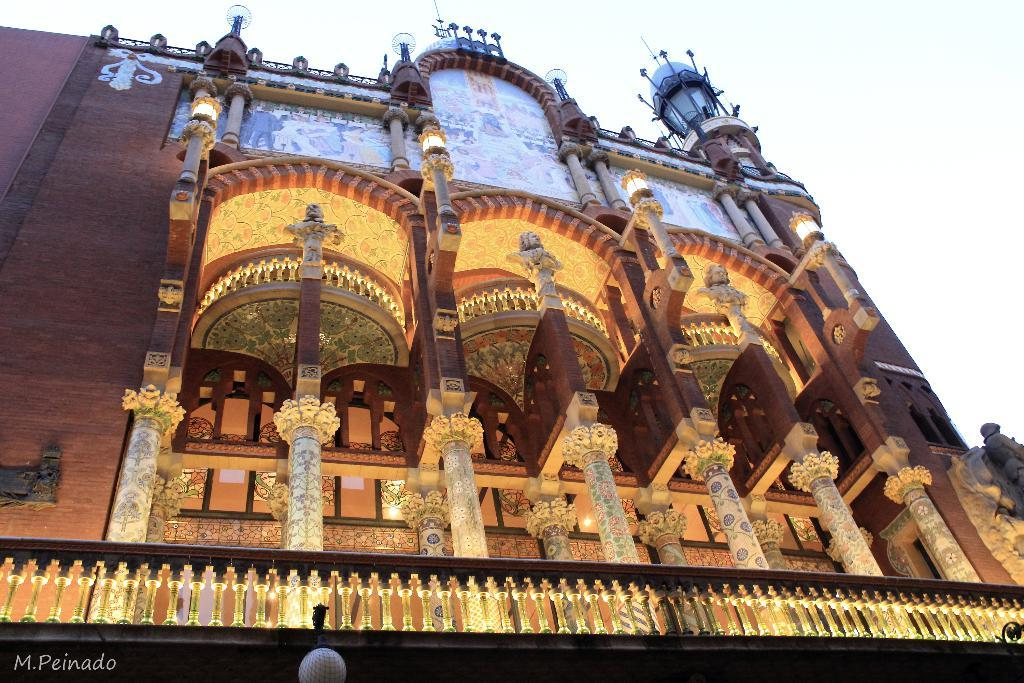What type of structure is present in the image? There is a building in the image. What architectural feature can be seen in the image? There is a pillar in the image. Is there any source of illumination visible in the image? Yes, there is a light in the image. What other structural element is present in the image? There is a wall in the image. What can be seen in the background of the image? The sky is visible in the image. What type of lipstick is being used on the toothpaste in the image? There is no lipstick or toothpaste present in the image; it features a building, pillar, light, wall, and sky. 